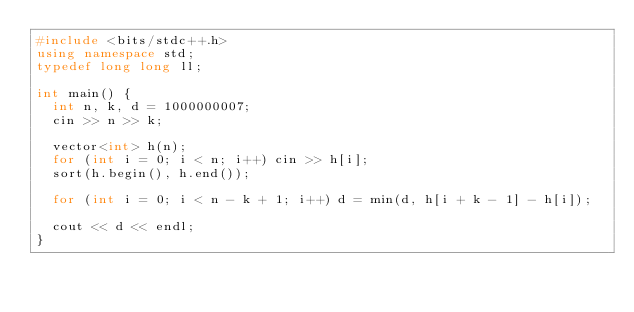Convert code to text. <code><loc_0><loc_0><loc_500><loc_500><_C++_>#include <bits/stdc++.h>
using namespace std;
typedef long long ll;

int main() {
  int n, k, d = 1000000007;
  cin >> n >> k;

  vector<int> h(n);
  for (int i = 0; i < n; i++) cin >> h[i];
  sort(h.begin(), h.end());

  for (int i = 0; i < n - k + 1; i++) d = min(d, h[i + k - 1] - h[i]);

  cout << d << endl;
}</code> 